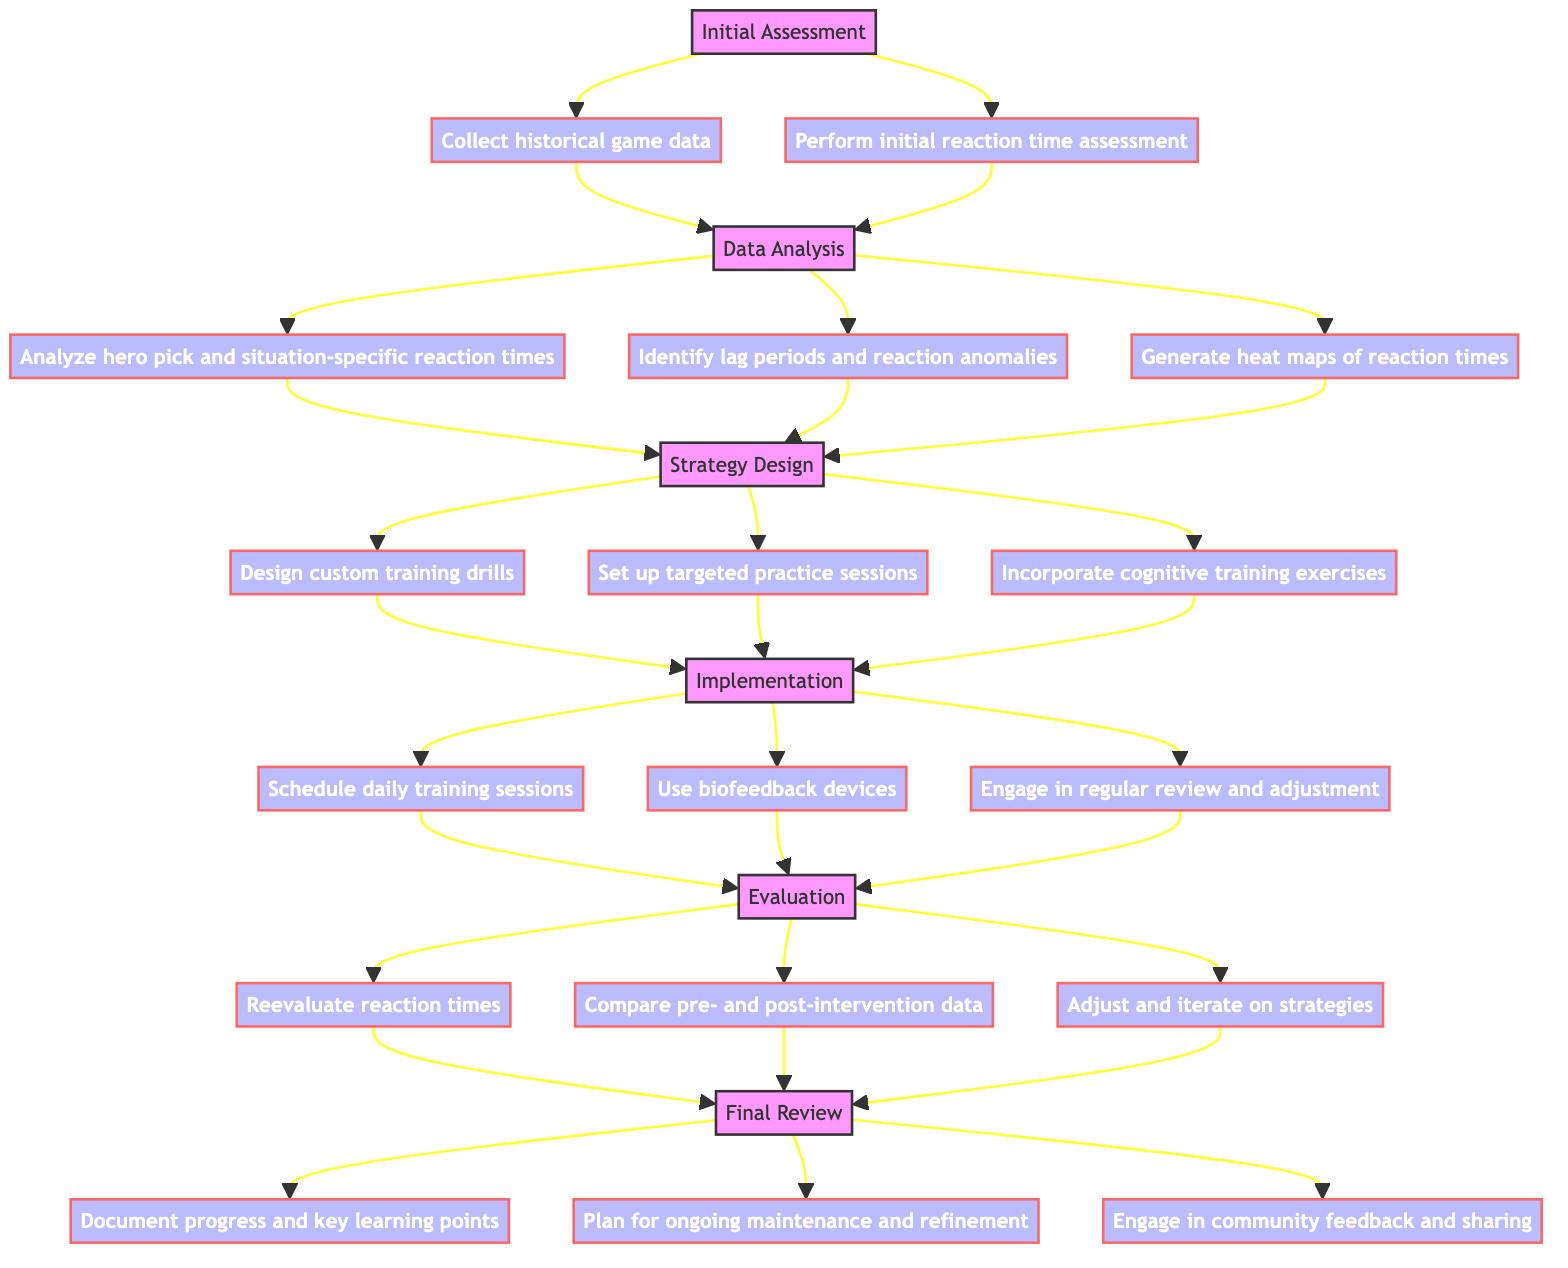What is the first phase of the Clinical Pathway? The diagram starts with the "Initial Assessment" phase, which is the first labeled section before any arrows or activities are shown.
Answer: Initial Assessment How many activities are in Phase 1? Phase 1, titled "Data Analysis," contains three activities connected by arrows leading to the next phase, making it clear there are three distinct tasks.
Answer: 3 What activities follow the "Initial Assessment"? The activities following "Initial Assessment" lead to Phase 1 and are both "Collect historical game data" and "Perform initial reaction time assessment," which are the immediate next steps of action.
Answer: Collect historical game data, Perform initial reaction time assessment Which phase involves evaluating reaction times using new game data? The "Evaluation" phase specifically mentions reassessing reaction times, suggesting that it focuses on reviewing improvements based on data collected after strategies have been implemented.
Answer: Evaluation What is the last activity listed in the diagram? The last phase, "Final Review," contains three activities, the last of which is "Engage in community feedback and sharing of best practices," indicating a focus on collaboration and knowledge sharing.
Answer: Engage in community feedback and sharing of best practices Which phase includes the use of biofeedback devices? The "Implementation" phase involves the use of biofeedback devices as one of its activities, indicating a practical application during training sessions to monitor performance effectively.
Answer: Implementation What type of training is incorporated in Phase 2? Phase 2, "Strategy Design," mentions incorporating cognitive training exercises from platforms like Lumosity, which indicates the phase's focus on enhancing cognitive skills alongside gameplay training.
Answer: Cognitive training exercises How does the pathway progress from Phase 3 to Phase 4? The transition from Phase 3, "Implementation," to Phase 4, "Evaluation," occurs after completing the activities of scheduling training sessions, using biofeedback devices, and reviewing strategies, implying a systematic flow from active training to reviewing outcomes.
Answer: Implementation to Evaluation In which phase are heat maps generated? The generation of heat maps is a specified activity in Phase 1, "Data Analysis," indicating this is when detailed data analytics are performed to identify areas needing improvement.
Answer: Data Analysis 